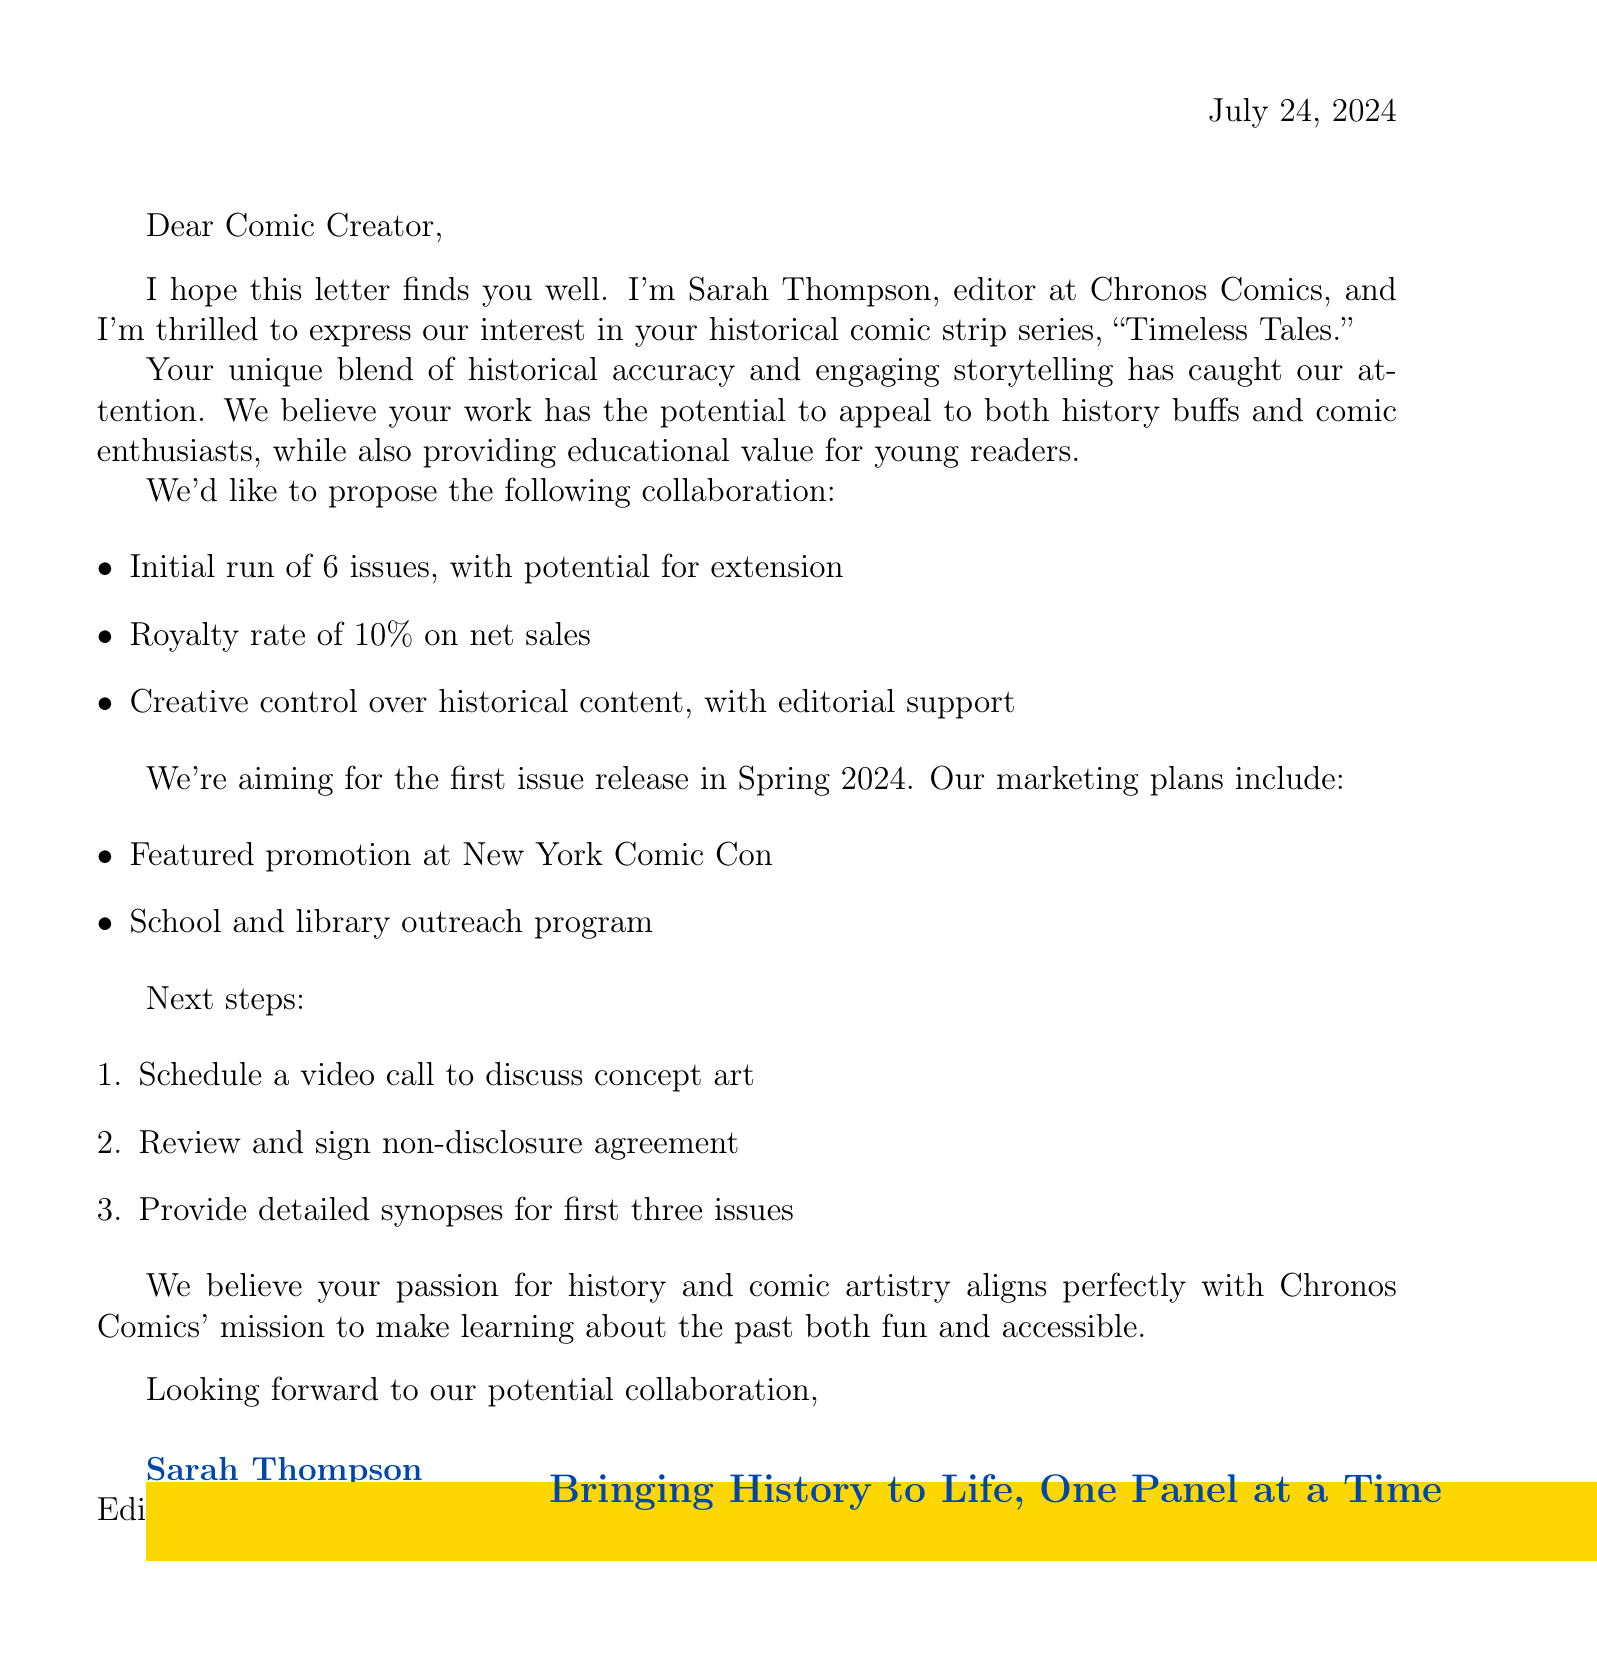What is the name of the publisher? The publisher's name is mentioned clearly in the document as Chronos Comics.
Answer: Chronos Comics Who is the editor of the comic book publisher? The editor's name, as stated in the letter, is Sarah Thompson.
Answer: Sarah Thompson How many issues are planned for the initial run? The document specifies an initial run of 6 issues for the comic series.
Answer: 6 issues What is the royalty rate offered on net sales? The letter clearly states that the royalty rate on net sales is 10 percent.
Answer: 10 percent When is the first issue of the comic series expected to be released? The publication timeline indicates that the first issue is set for release in Spring 2024.
Answer: Spring 2024 What marketing plan involves an event? One of the marketing plans includes a featured promotion at New York Comic Con, which is an event.
Answer: New York Comic Con What is one of the next steps mentioned in the letter? The document lists scheduling a video call to discuss concept art as one of the next steps.
Answer: Schedule a video call What is the specific educational goal mentioned for the comic series? The letter emphasizes that the comic strip series aims to provide educational value for young readers.
Answer: Educational value for young readers What is the closing statement in the letter? The closing statement expresses that the publisher believes the creator's passion aligns with their mission, summarizing the collaboration intent.
Answer: We believe your passion for history and comic artistry aligns perfectly with Chronos Comics' mission to make learning about the past both fun and accessible 